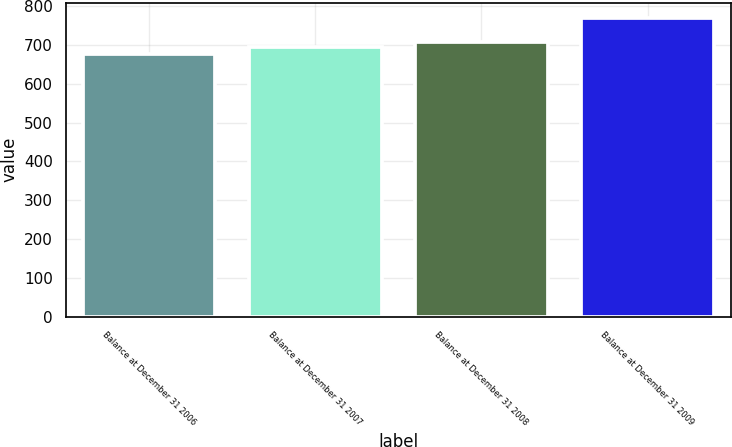Convert chart to OTSL. <chart><loc_0><loc_0><loc_500><loc_500><bar_chart><fcel>Balance at December 31 2006<fcel>Balance at December 31 2007<fcel>Balance at December 31 2008<fcel>Balance at December 31 2009<nl><fcel>677<fcel>696<fcel>709<fcel>770<nl></chart> 